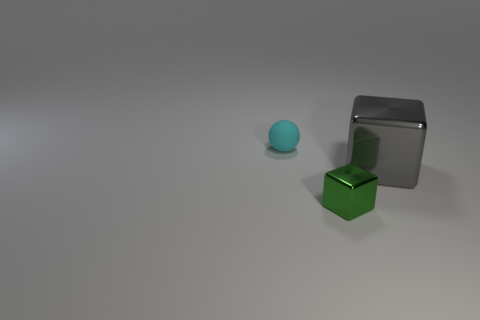What kind of material do the objects seem to be made of, and how can you tell? The objects appear to be made of different materials. The blue sphere has a matte finish, suggesting a non-reflective, possibly soft or opaque material. The green cube looks like it has a slightly reflective surface, indicating a harder, possibly metallic material. The gray cube has the most reflective surface among the three, suggestive of a polished metal or a glossy plastic. 